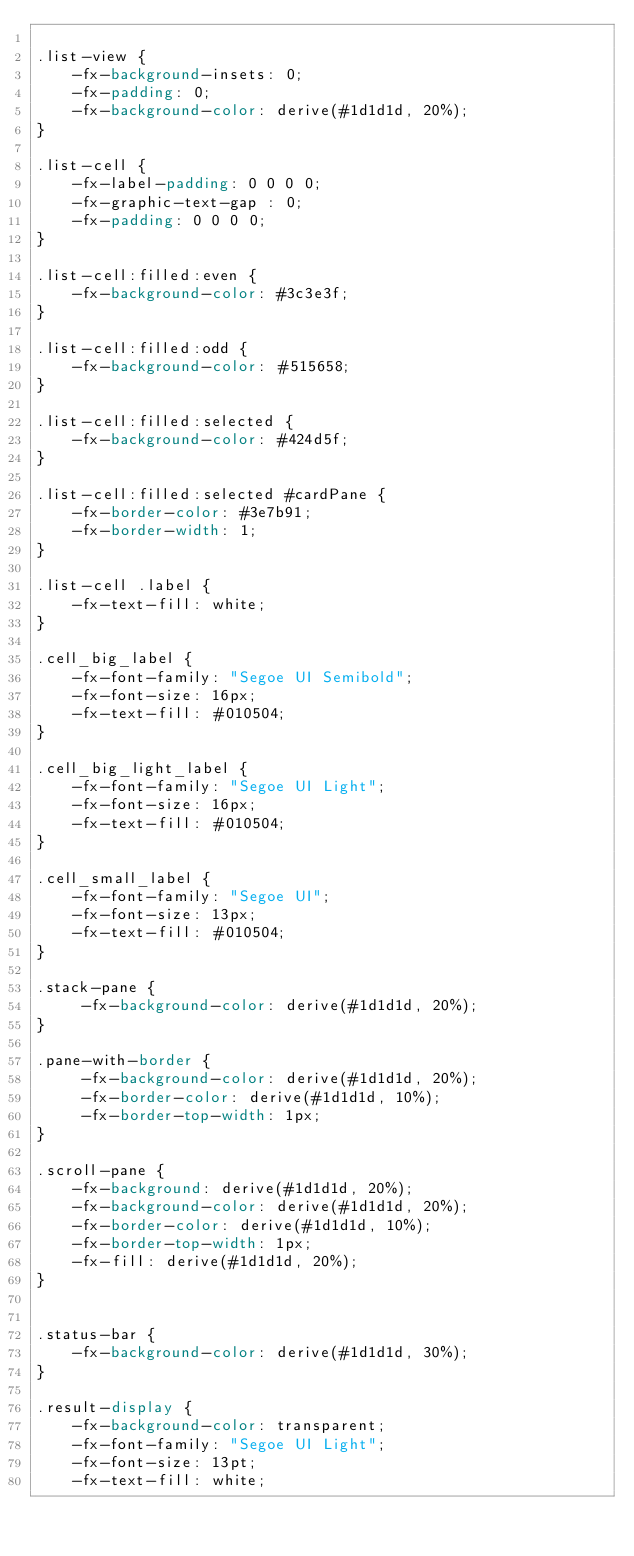<code> <loc_0><loc_0><loc_500><loc_500><_CSS_>
.list-view {
    -fx-background-insets: 0;
    -fx-padding: 0;
    -fx-background-color: derive(#1d1d1d, 20%);
}

.list-cell {
    -fx-label-padding: 0 0 0 0;
    -fx-graphic-text-gap : 0;
    -fx-padding: 0 0 0 0;
}

.list-cell:filled:even {
    -fx-background-color: #3c3e3f;
}

.list-cell:filled:odd {
    -fx-background-color: #515658;
}

.list-cell:filled:selected {
    -fx-background-color: #424d5f;
}

.list-cell:filled:selected #cardPane {
    -fx-border-color: #3e7b91;
    -fx-border-width: 1;
}

.list-cell .label {
    -fx-text-fill: white;
}

.cell_big_label {
    -fx-font-family: "Segoe UI Semibold";
    -fx-font-size: 16px;
    -fx-text-fill: #010504;
}

.cell_big_light_label {
    -fx-font-family: "Segoe UI Light";
    -fx-font-size: 16px;
    -fx-text-fill: #010504;
}

.cell_small_label {
    -fx-font-family: "Segoe UI";
    -fx-font-size: 13px;
    -fx-text-fill: #010504;
}

.stack-pane {
     -fx-background-color: derive(#1d1d1d, 20%);
}

.pane-with-border {
     -fx-background-color: derive(#1d1d1d, 20%);
     -fx-border-color: derive(#1d1d1d, 10%);
     -fx-border-top-width: 1px;
}

.scroll-pane {
    -fx-background: derive(#1d1d1d, 20%);
    -fx-background-color: derive(#1d1d1d, 20%);
    -fx-border-color: derive(#1d1d1d, 10%);
    -fx-border-top-width: 1px;
    -fx-fill: derive(#1d1d1d, 20%);
}


.status-bar {
    -fx-background-color: derive(#1d1d1d, 30%);
}

.result-display {
    -fx-background-color: transparent;
    -fx-font-family: "Segoe UI Light";
    -fx-font-size: 13pt;
    -fx-text-fill: white;</code> 